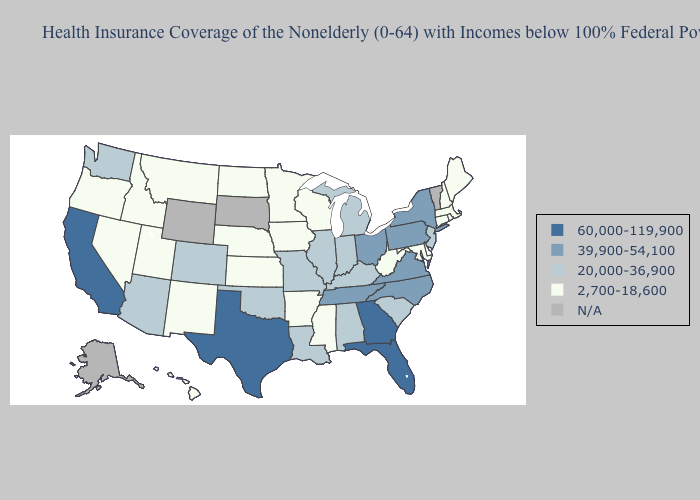Does Kentucky have the highest value in the USA?
Write a very short answer. No. What is the value of Wisconsin?
Quick response, please. 2,700-18,600. Among the states that border Indiana , does Kentucky have the highest value?
Quick response, please. No. Among the states that border Florida , does Georgia have the lowest value?
Concise answer only. No. What is the value of Alaska?
Be succinct. N/A. What is the highest value in the MidWest ?
Short answer required. 39,900-54,100. What is the lowest value in the USA?
Be succinct. 2,700-18,600. Does Rhode Island have the lowest value in the Northeast?
Keep it brief. Yes. What is the lowest value in the USA?
Concise answer only. 2,700-18,600. What is the highest value in the West ?
Be succinct. 60,000-119,900. Does the first symbol in the legend represent the smallest category?
Short answer required. No. Among the states that border Texas , which have the lowest value?
Answer briefly. Arkansas, New Mexico. What is the value of Arkansas?
Write a very short answer. 2,700-18,600. Which states have the lowest value in the USA?
Short answer required. Arkansas, Connecticut, Delaware, Hawaii, Idaho, Iowa, Kansas, Maine, Maryland, Massachusetts, Minnesota, Mississippi, Montana, Nebraska, Nevada, New Hampshire, New Mexico, North Dakota, Oregon, Rhode Island, Utah, West Virginia, Wisconsin. 